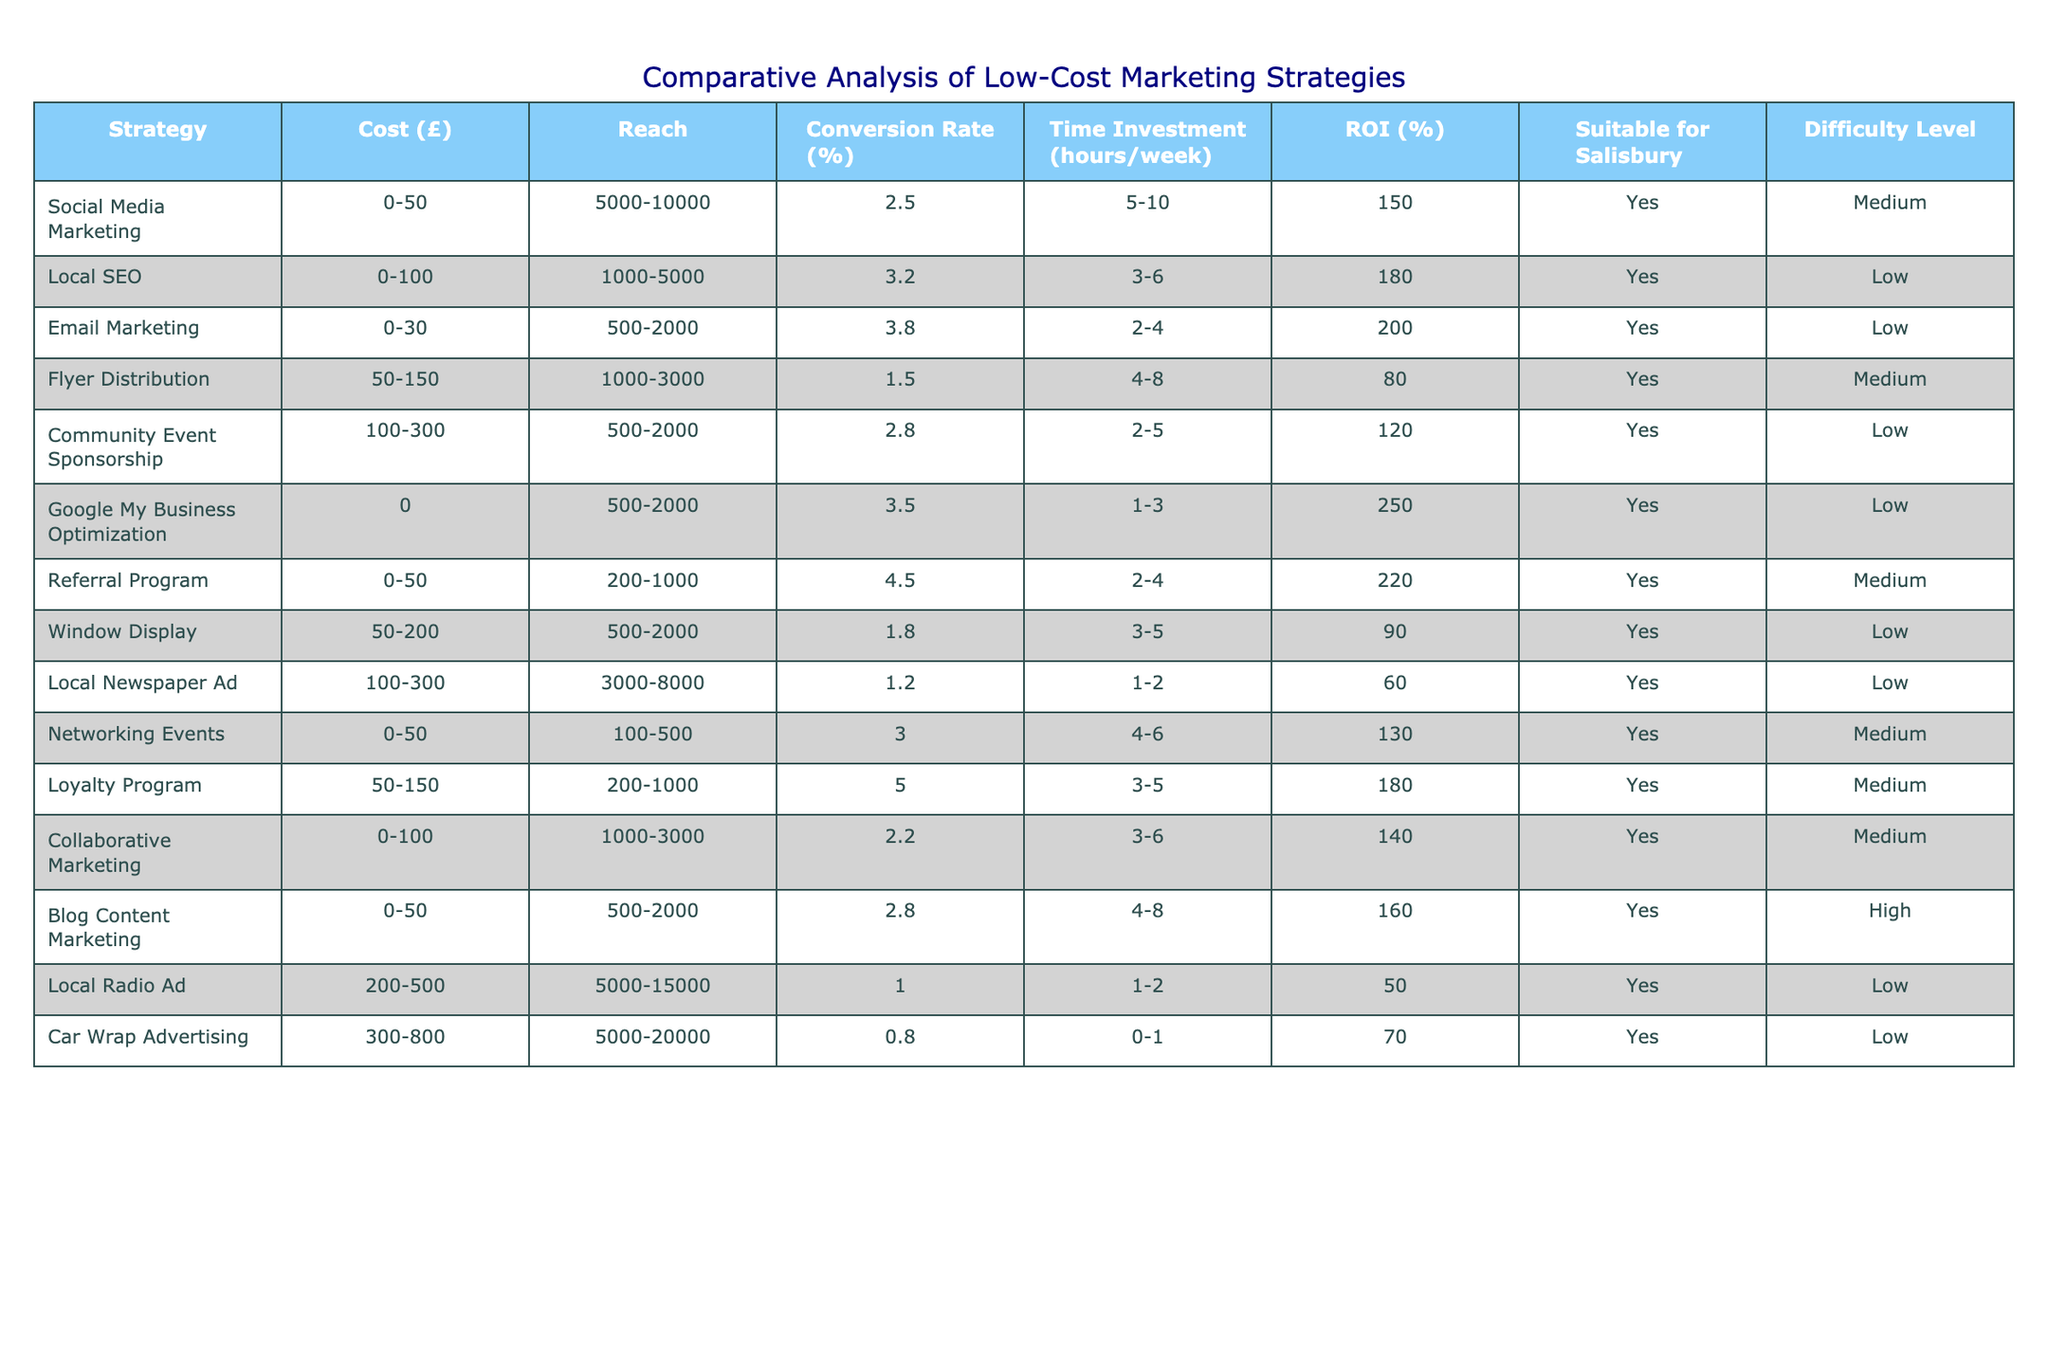What marketing strategy has the highest conversion rate? The table shows that 'Loyalty Program' has the highest conversion rate at 5.0%.
Answer: 5.0% Which marketing strategies are suitable for Salisbury and have low difficulty levels? By looking at the table, 'Local SEO', 'Email Marketing', 'Community Event Sponsorship', 'Google My Business Optimization', 'Window Display', 'Local Newspaper Ad', and 'Car Wrap Advertising' are marked as suitable for Salisbury and have low difficulty levels.
Answer: 6 strategies What is the difference in cost between 'Flyer Distribution' and 'Loyalty Program'? 'Flyer Distribution' has a cost range of £50-150 and 'Loyalty Program' has a cost range of £50-150, so the difference in their minimum cost is 50 - 50 = 0 and maximum cost is 150 - 150 = 0.
Answer: £0 Which strategy offers the best ROI relative to its cost? The 'Google My Business Optimization' has the highest ROI at 250%, but there's no cost associated with it, so it's not directly comparable. However, if we consider direct costs, the 'Email Marketing' strategy has a good ROI of 200% for the lowest cost (£0-30).
Answer: Email Marketing Can you identify all strategies that have a reach of over 5000? By checking the table, the strategies with a reach of over 5000 are 'Social Media Marketing', 'Local Radio Ad', and 'Car Wrap Advertising'.
Answer: 3 strategies How many hours weekly are required for 'Blog Content Marketing'? The time investment listed for 'Blog Content Marketing' is between 4-8 hours per week.
Answer: 4-8 hours Is 'Networking Events' a low-cost marketing strategy? 'Networking Events' ranges from £0-50, which falls under the low-cost category.
Answer: Yes What is the average ROI of all strategies that require a time investment of 4 hours or more per week? The strategies that require 4 hours or more are 'Flyer Distribution', 'Networking Events', 'Loyalty Program', 'Blog Content Marketing', leading to an average ROI calculation of (80 + 130 + 180 + 160) / 4 = 137.5.
Answer: 137.5% What is the reach of 'Car Wrap Advertising'? The reach of 'Car Wrap Advertising' is 5000-20000.
Answer: 5000-20000 Which strategy has the lowest conversion rate? 'Local Radio Ad' has the lowest conversion rate at 1.0%.
Answer: 1.0% 